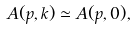Convert formula to latex. <formula><loc_0><loc_0><loc_500><loc_500>A ( { p } , { k } ) \simeq A ( { p } , { 0 } ) ,</formula> 